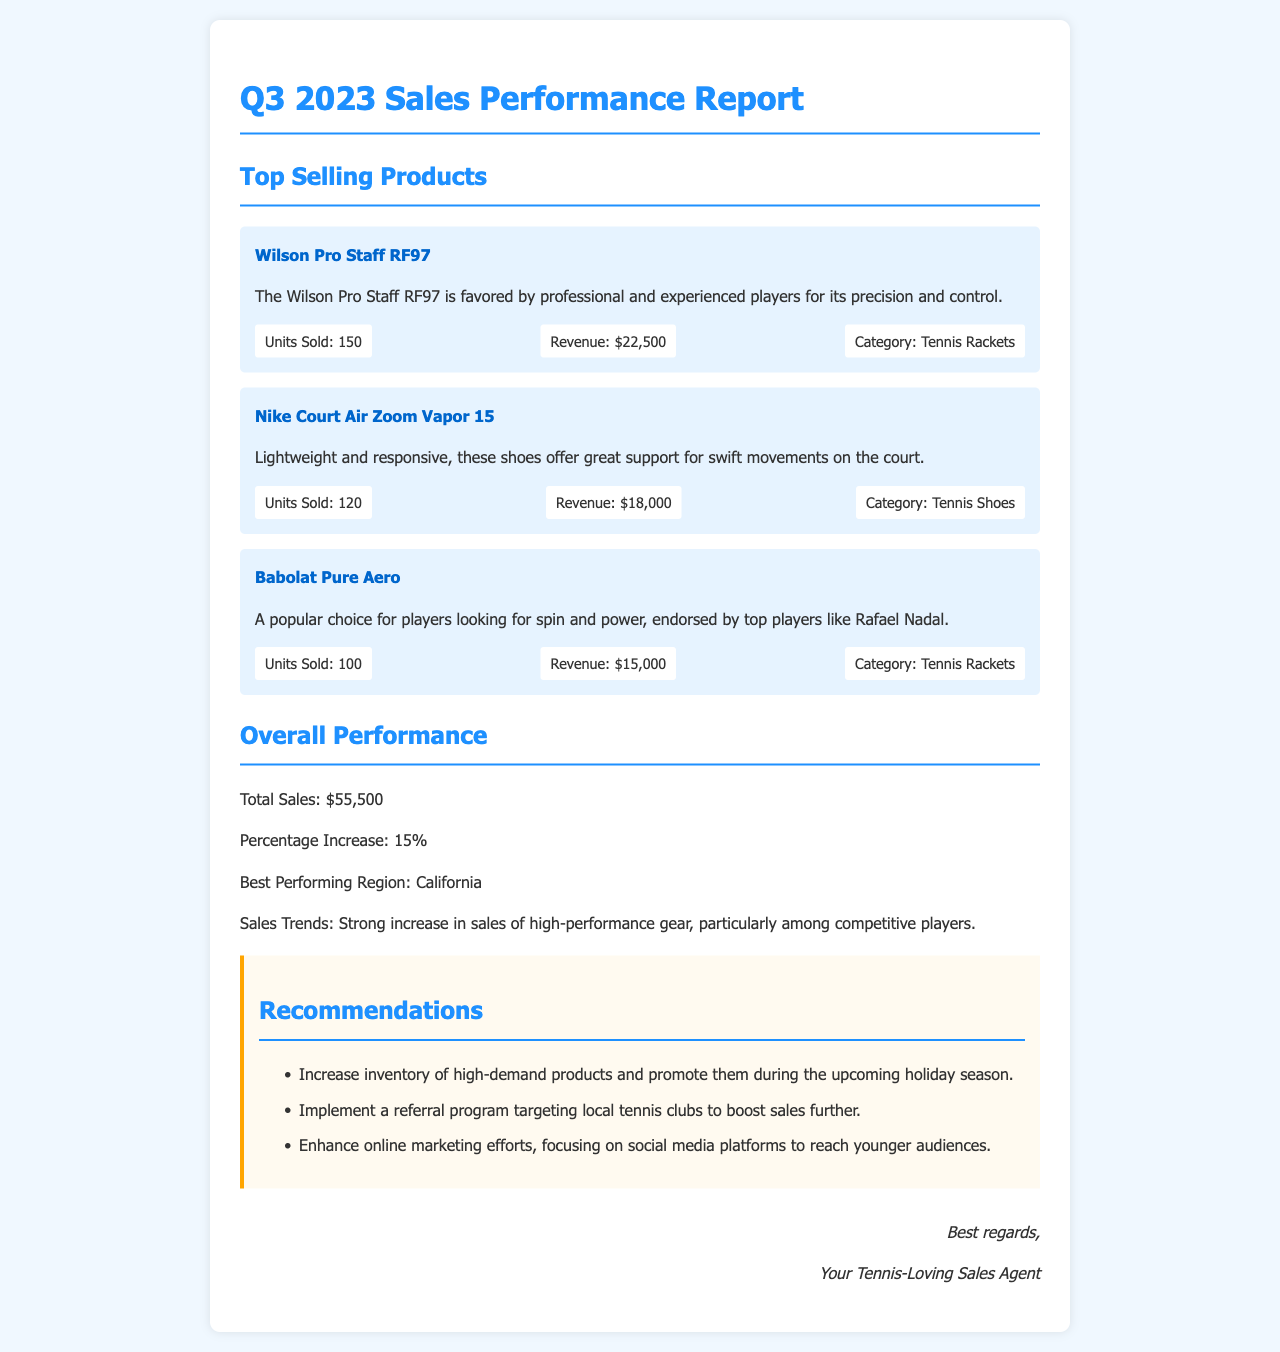What were the total sales for Q3 2023? The total sales amount is directly mentioned in the document under "Overall Performance."
Answer: $55,500 Which product generated the highest revenue? The product with the highest revenue can be found in the "Top Selling Products" section, specifically looking for the revenue figures.
Answer: Wilson Pro Staff RF97 What is the percentage increase in sales compared to the previous quarter? The percentage increase is stated explicitly in the "Overall Performance" section of the document.
Answer: 15% How many units of Nike Court Air Zoom Vapor 15 were sold? This information is retrieved from the product stats listed under "Top Selling Products."
Answer: 120 In which region were sales the best? The best performing region is clearly specified in the "Overall Performance" section.
Answer: California What is a recommendation from the report? Recommendations are listed in the "Recommendations" section, which can be summarized by selecting one of the points mentioned.
Answer: Increase inventory of high-demand products What types of products are showing strong sales trends? Sales trends regarding high-performance gear are discussed in the "Overall Performance" section.
Answer: High-performance gear Which tennis legend endorses the Babolat Pure Aero? The document states that the Babolat Pure Aero is endorsed by a specific player in the product description.
Answer: Rafael Nadal 